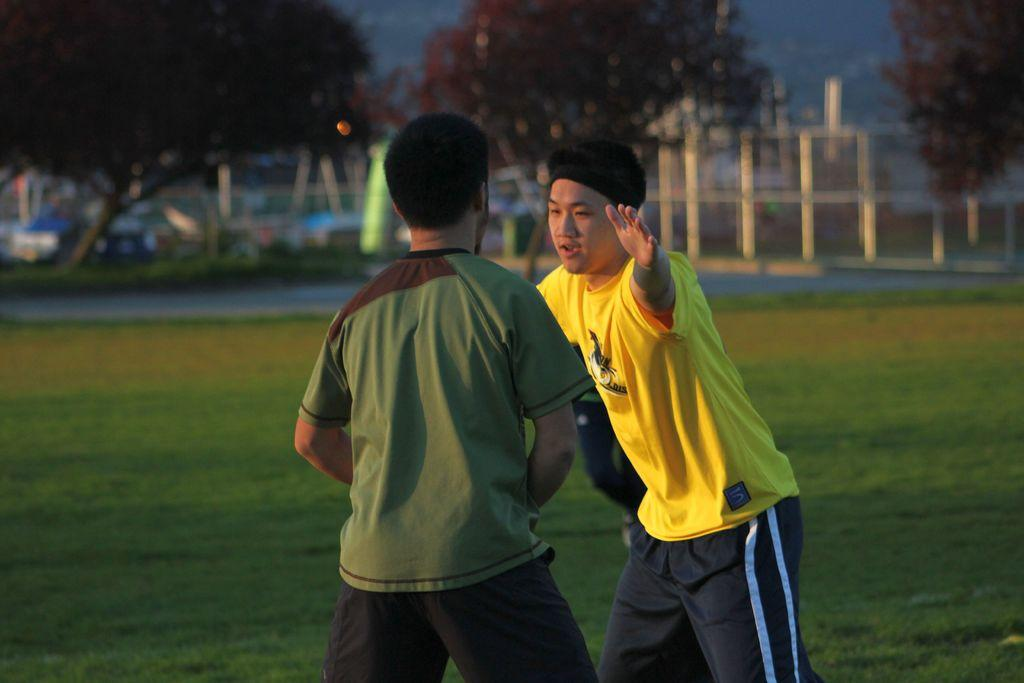What can be seen in the foreground of the image? There are persons standing in the front of the image. What type of vegetation is present on the ground in the center of the image? There is grass on the ground in the center of the image. What can be seen in the distance in the image? There are trees in the background of the image. What architectural feature is visible in the background of the image? There is a fence in the background of the image. What type of wealth can be seen in the image? There is no indication of wealth in the image; it features persons standing in front of grass, trees, and a fence. How does the banana affect the overall composition of the image? There is no banana present in the image, so it cannot have any effect on the composition. 